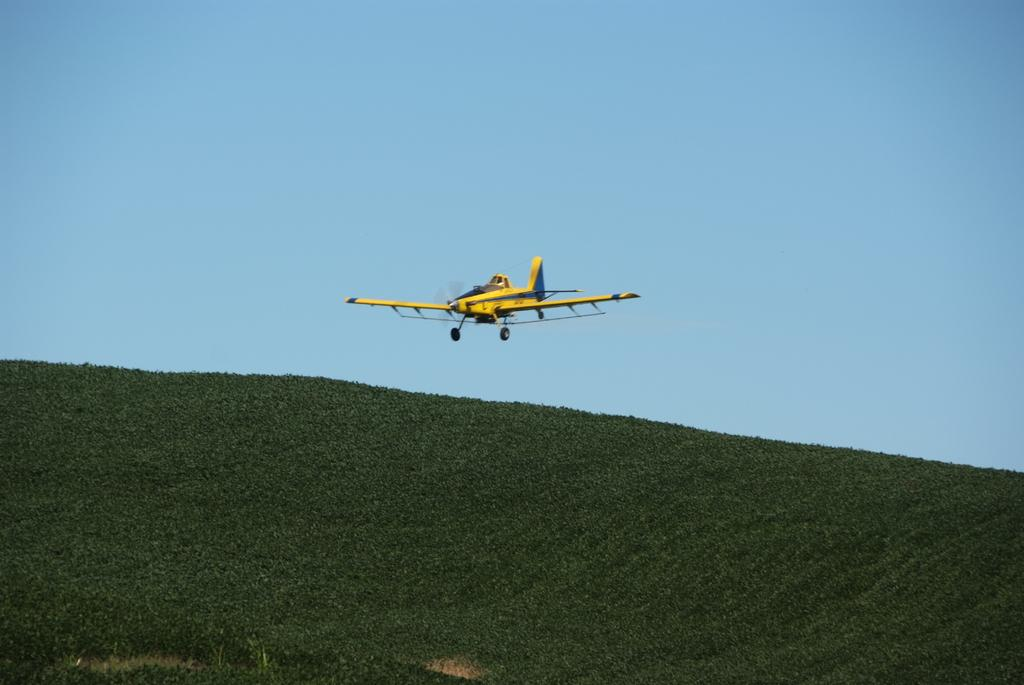What type of vegetation or plants can be seen at the bottom of the image? There is greenery at the bottom side of the image. What is the main subject in the center of the image? There is an air craft in the center of the image. How many children are playing with the head of the air craft in the image? There are no children or heads of air craft present in the image. 